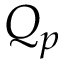Convert formula to latex. <formula><loc_0><loc_0><loc_500><loc_500>Q _ { p }</formula> 